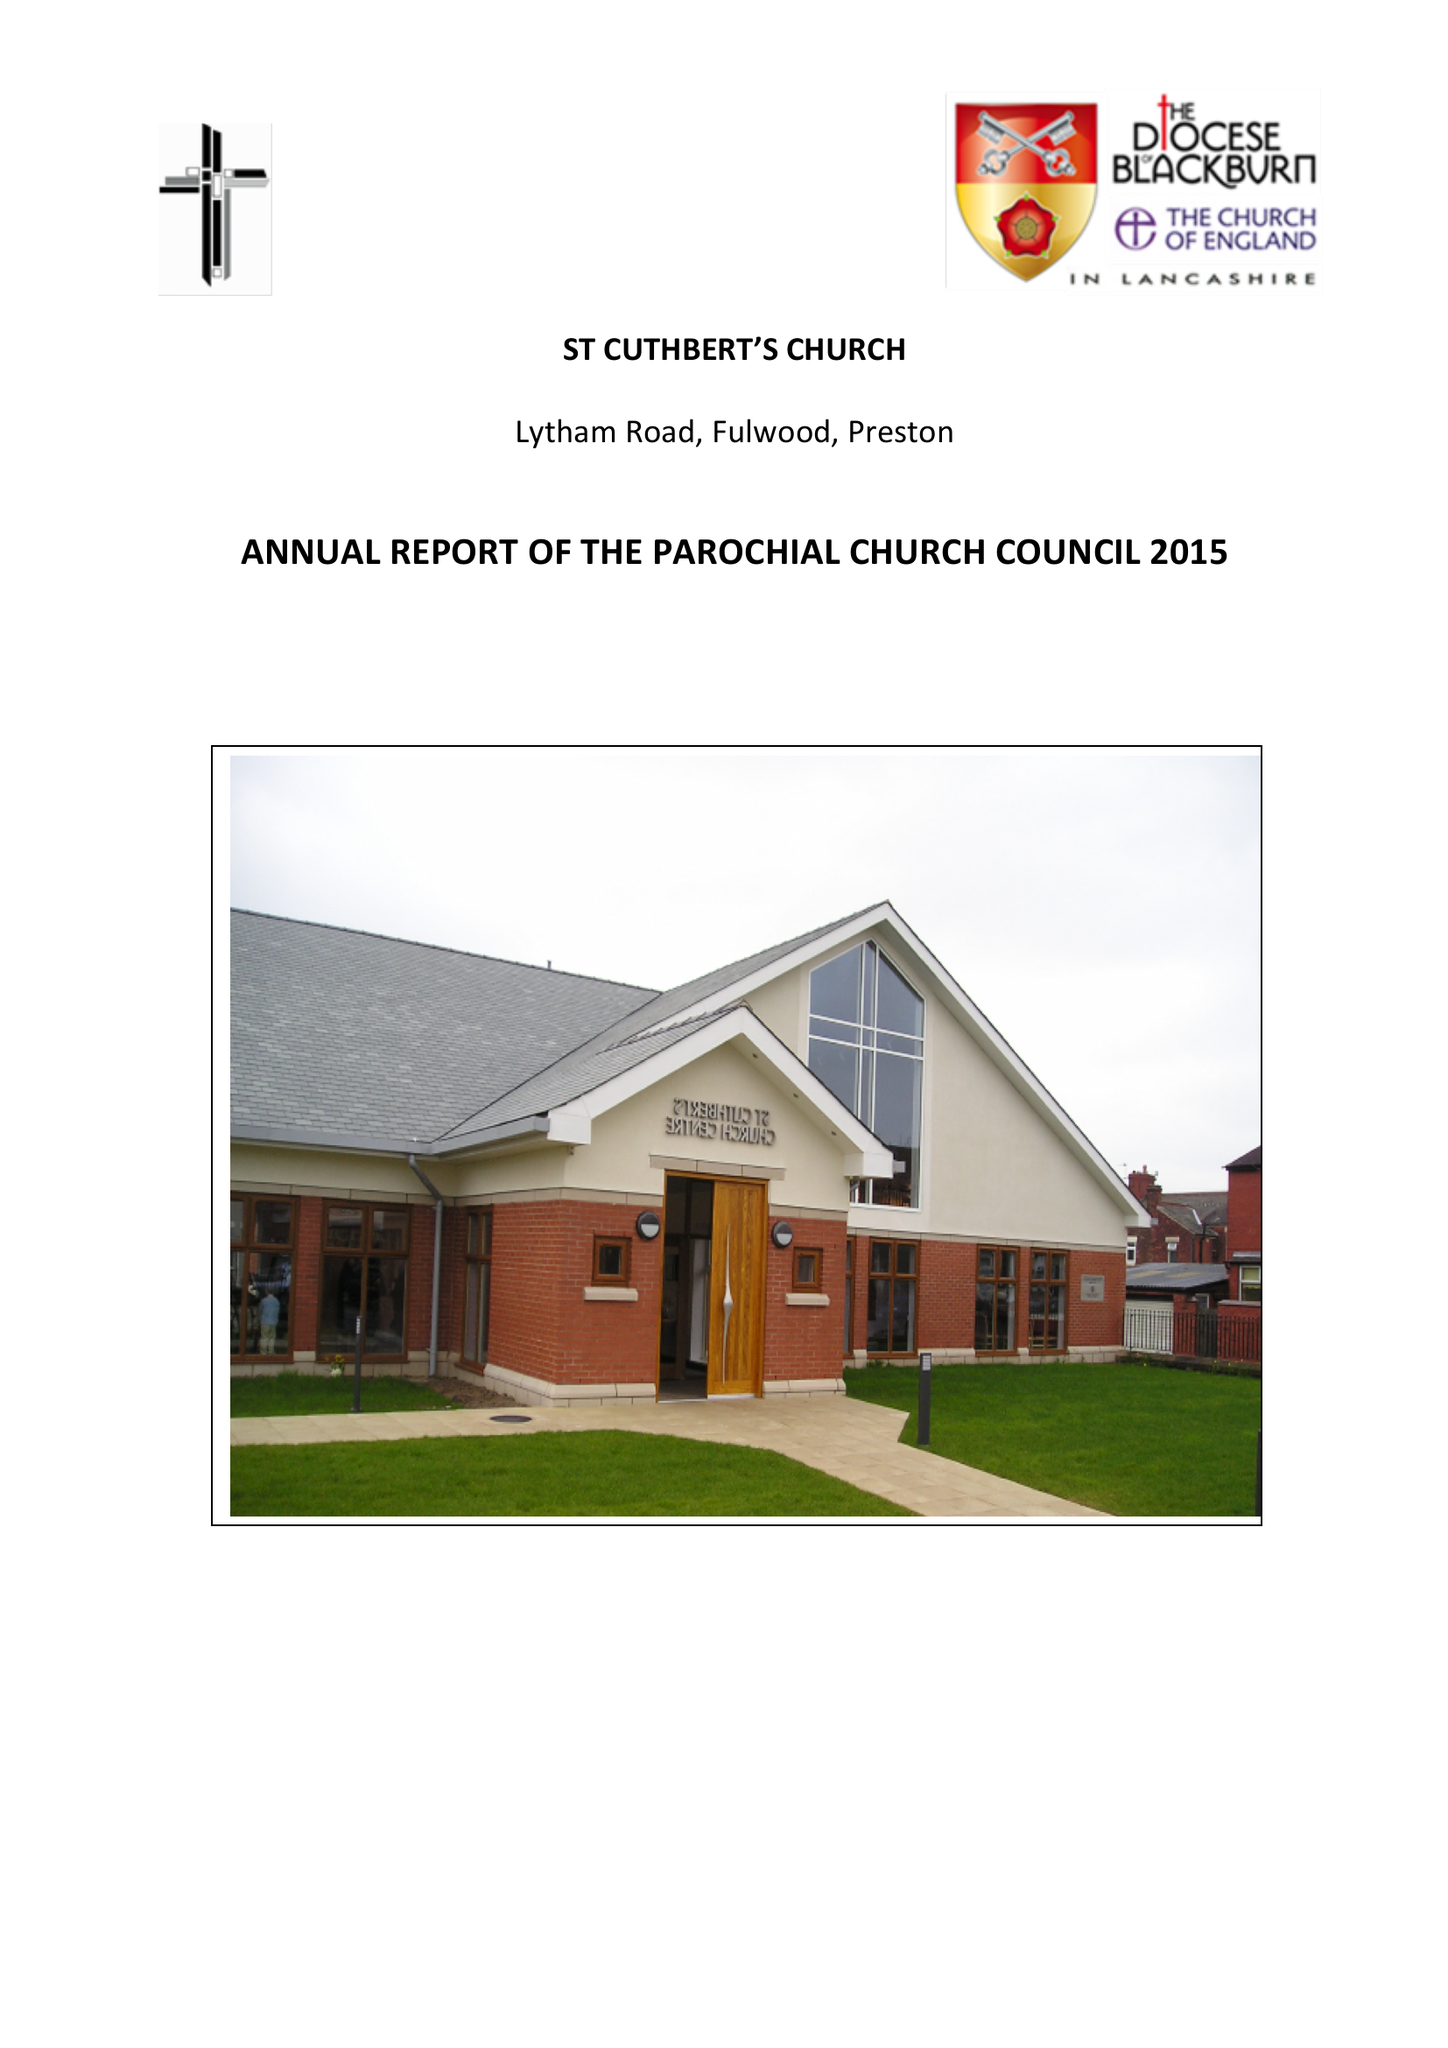What is the value for the spending_annually_in_british_pounds?
Answer the question using a single word or phrase. 157964.00 